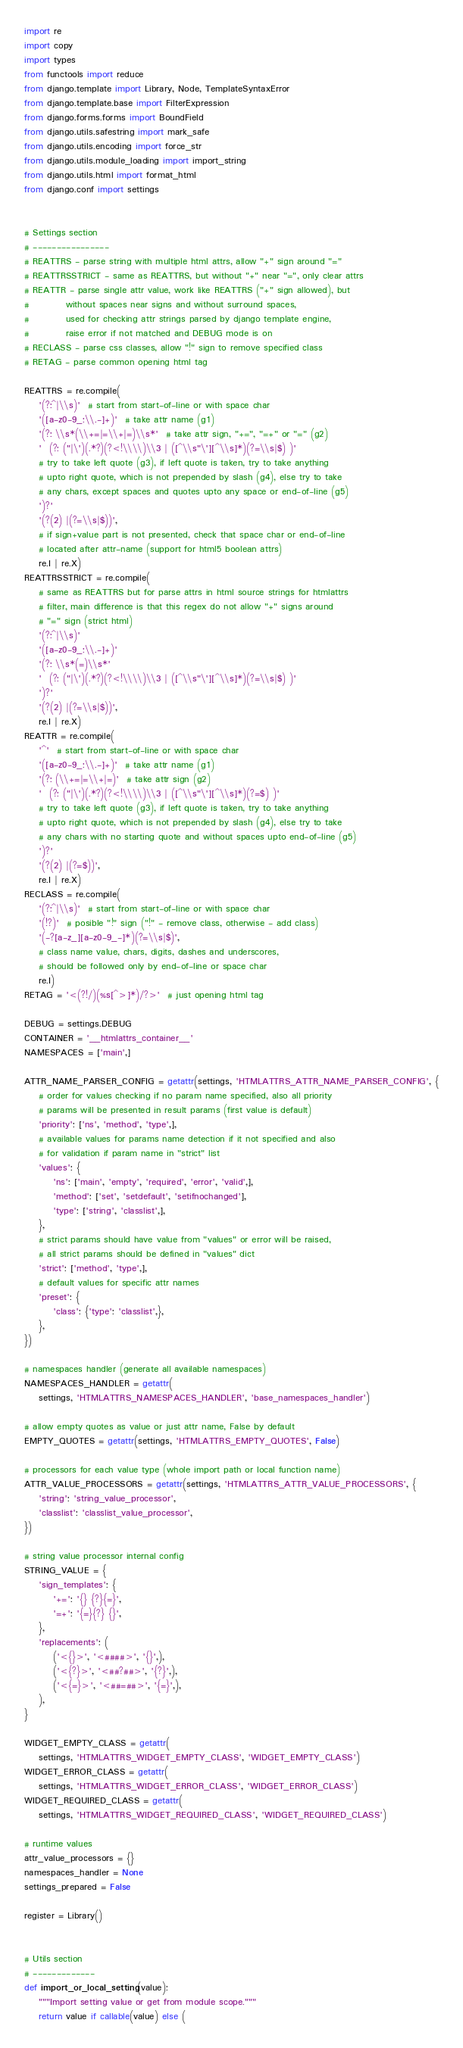Convert code to text. <code><loc_0><loc_0><loc_500><loc_500><_Python_>import re
import copy
import types
from functools import reduce
from django.template import Library, Node, TemplateSyntaxError
from django.template.base import FilterExpression
from django.forms.forms import BoundField
from django.utils.safestring import mark_safe
from django.utils.encoding import force_str
from django.utils.module_loading import import_string
from django.utils.html import format_html
from django.conf import settings


# Settings section
# ----------------
# REATTRS - parse string with multiple html attrs, allow "+" sign around "="
# REATTRSSTRICT - same as REATTRS, but without "+" near "=", only clear attrs
# REATTR - parse single attr value, work like REATTRS ("+" sign allowed), but
#          without spaces near signs and without surround spaces,
#          used for checking attr strings parsed by django template engine,
#          raise error if not matched and DEBUG mode is on
# RECLASS - parse css classes, allow "!" sign to remove specified class
# RETAG - parse common opening html tag

REATTRS = re.compile(
    '(?:^|\\s)'  # start from start-of-line or with space char
    '([a-z0-9_:\\.-]+)'  # take attr name (g1)
    '(?: \\s*(\\+=|=\\+|=)\\s*'  # take attr sign, "+=", "=+" or "=" (g2)
    '  (?: ("|\')(.*?)(?<!\\\\)\\3 | ([^\\s"\'][^\\s]*)(?=\\s|$) )'
    # try to take left quote (g3), if left quote is taken, try to take anything
    # upto right quote, which is not prepended by slash (g4), else try to take
    # any chars, except spaces and quotes upto any space or end-of-line (g5)
    ')?'
    '(?(2) |(?=\\s|$))',
    # if sign+value part is not presented, check that space char or end-of-line
    # located after attr-name (support for html5 boolean attrs)
    re.I | re.X)
REATTRSSTRICT = re.compile(
    # same as REATTRS but for parse attrs in html source strings for htmlattrs
    # filter, main difference is that this regex do not allow "+" signs around
    # "=" sign (strict html)
    '(?:^|\\s)'
    '([a-z0-9_:\\.-]+)'
    '(?: \\s*(=)\\s*'
    '  (?: ("|\')(.*?)(?<!\\\\)\\3 | ([^\\s"\'][^\\s]*)(?=\\s|$) )'
    ')?'
    '(?(2) |(?=\\s|$))',
    re.I | re.X)
REATTR = re.compile(
    '^'  # start from start-of-line or with space char
    '([a-z0-9_:\\.-]+)'  # take attr name (g1)
    '(?: (\\+=|=\\+|=)'  # take attr sign (g2)
    '  (?: ("|\')(.*?)(?<!\\\\)\\3 | ([^\\s"\'][^\\s]*)(?=$) )'
    # try to take left quote (g3), if left quote is taken, try to take anything
    # upto right quote, which is not prepended by slash (g4), else try to take
    # any chars with no starting quote and without spaces upto end-of-line (g5)
    ')?'
    '(?(2) |(?=$))',
    re.I | re.X)
RECLASS = re.compile(
    '(?:^|\\s)'  # start from start-of-line or with space char
    '(!?)'  # posible "!" sign ("!" - remove class, otherwise - add class)
    '(-?[a-z_][a-z0-9_-]*)(?=\\s|$)',
    # class name value, chars, digits, dashes and underscores,
    # should be followed only by end-of-line or space char
    re.I)
RETAG = '<(?!/)(%s[^>]*)/?>'  # just opening html tag

DEBUG = settings.DEBUG
CONTAINER = '__htmlattrs_container__'
NAMESPACES = ['main',]

ATTR_NAME_PARSER_CONFIG = getattr(settings, 'HTMLATTRS_ATTR_NAME_PARSER_CONFIG', {
    # order for values checking if no param name specified, also all priority
    # params will be presented in result params (first value is default)
    'priority': ['ns', 'method', 'type',],
    # available values for params name detection if it not specified and also
    # for validation if param name in "strict" list
    'values': {
        'ns': ['main', 'empty', 'required', 'error', 'valid',],
        'method': ['set', 'setdefault', 'setifnochanged'],
        'type': ['string', 'classlist',],
    },
    # strict params should have value from "values" or error will be raised,
    # all strict params should be defined in "values" dict
    'strict': ['method', 'type',],
    # default values for specific attr names
    'preset': {
        'class': {'type': 'classlist',},
    },
})

# namespaces handler (generate all available namespaces)
NAMESPACES_HANDLER = getattr(
    settings, 'HTMLATTRS_NAMESPACES_HANDLER', 'base_namespaces_handler')

# allow empty quotes as value or just attr name, False by default
EMPTY_QUOTES = getattr(settings, 'HTMLATTRS_EMPTY_QUOTES', False)

# processors for each value type (whole import path or local function name)
ATTR_VALUE_PROCESSORS = getattr(settings, 'HTMLATTRS_ATTR_VALUE_PROCESSORS', {
    'string': 'string_value_processor',
    'classlist': 'classlist_value_processor',
})

# string value processor internal config
STRING_VALUE = {
    'sign_templates': {
        '+=': '{} {?}{=}',
        '=+': '{=}{?} {}',
    },
    'replacements': (
        ('<{}>', '<####>', '{}',),
        ('<{?}>', '<##?##>', '{?}',),
        ('<{=}>', '<##=##>', '{=}',),
    ),
}

WIDGET_EMPTY_CLASS = getattr(
    settings, 'HTMLATTRS_WIDGET_EMPTY_CLASS', 'WIDGET_EMPTY_CLASS')
WIDGET_ERROR_CLASS = getattr(
    settings, 'HTMLATTRS_WIDGET_ERROR_CLASS', 'WIDGET_ERROR_CLASS')
WIDGET_REQUIRED_CLASS = getattr(
    settings, 'HTMLATTRS_WIDGET_REQUIRED_CLASS', 'WIDGET_REQUIRED_CLASS')

# runtime values
attr_value_processors = {}
namespaces_handler = None
settings_prepared = False

register = Library()


# Utils section
# -------------
def import_or_local_setting(value):
    """Import setting value or get from module scope."""
    return value if callable(value) else (</code> 